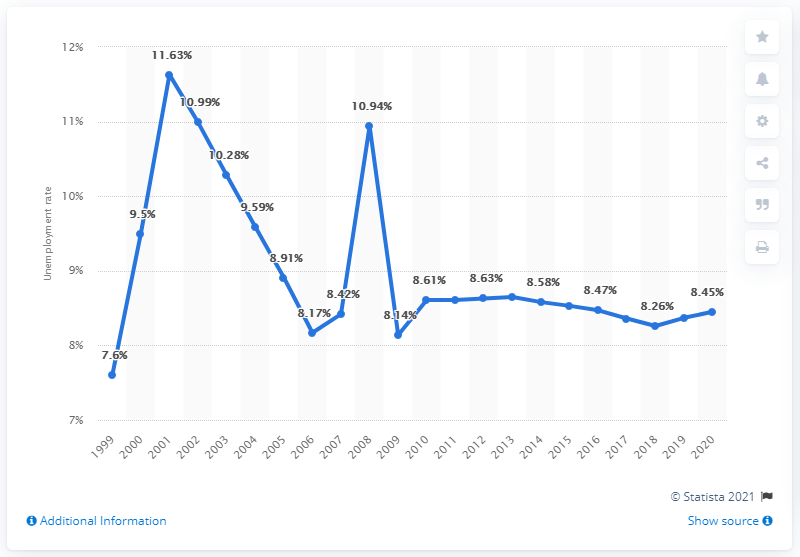Identify some key points in this picture. In 2020, the unemployment rate in Syria was 8.45%. The employment rate in Syria between 2020 and 1999 varied by 4.03%. The unemployment rate in Syria for the year 2018 was 8.26%. 